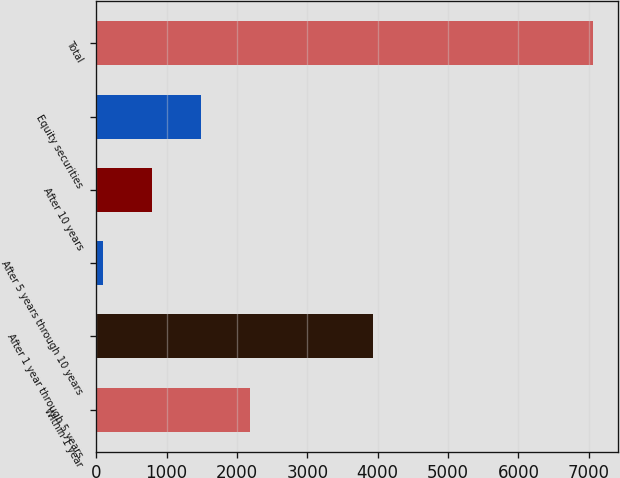Convert chart to OTSL. <chart><loc_0><loc_0><loc_500><loc_500><bar_chart><fcel>Within 1 year<fcel>After 1 year through 5 years<fcel>After 5 years through 10 years<fcel>After 10 years<fcel>Equity securities<fcel>Total<nl><fcel>2189.5<fcel>3929<fcel>103<fcel>798.5<fcel>1494<fcel>7058<nl></chart> 